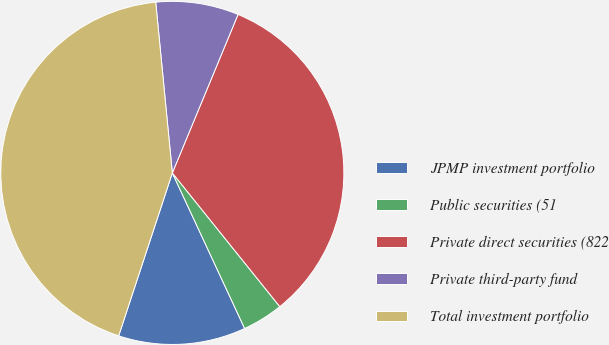Convert chart. <chart><loc_0><loc_0><loc_500><loc_500><pie_chart><fcel>JPMP investment portfolio<fcel>Public securities (51<fcel>Private direct securities (822<fcel>Private third-party fund<fcel>Total investment portfolio<nl><fcel>11.99%<fcel>3.85%<fcel>32.97%<fcel>7.8%<fcel>43.39%<nl></chart> 